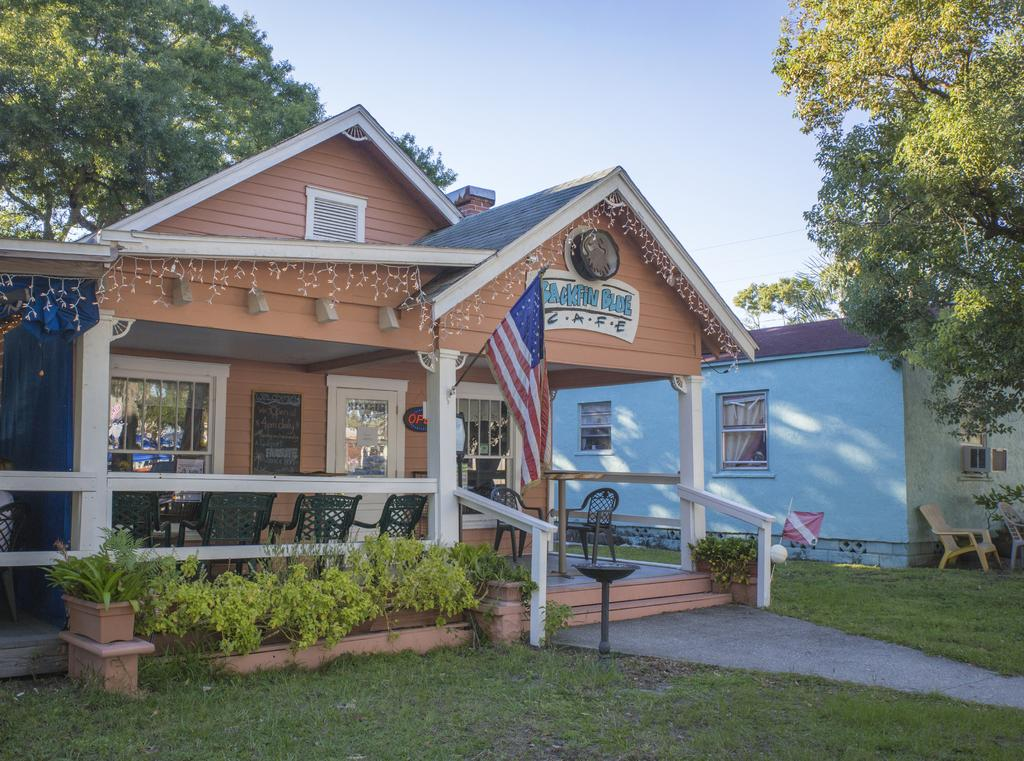What type of structures are present in the image? There is a group of buildings in the image. What other natural elements can be seen in the image? There are trees in the image. What type of furniture is visible on the floor? Chairs are placed on the floor in the image. What type of vegetation is present in the image? There is a group of plants in the image. What is visible in the background of the image? The sky is visible in the background of the image. What type of mint is growing in the image? There is no mint present in the image. What function does the calculator serve in the image? There is no calculator present in the image. 